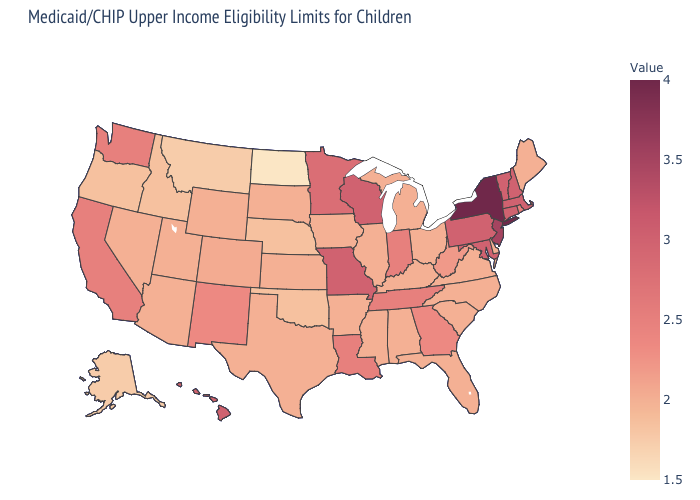Which states have the highest value in the USA?
Answer briefly. New York. Does Wisconsin have the highest value in the MidWest?
Concise answer only. Yes. Among the states that border West Virginia , does Virginia have the highest value?
Be succinct. No. Does North Dakota have the lowest value in the USA?
Concise answer only. Yes. Does Michigan have the highest value in the USA?
Give a very brief answer. No. Does Rhode Island have the lowest value in the Northeast?
Quick response, please. No. Does Wyoming have a higher value than North Dakota?
Answer briefly. Yes. Which states hav the highest value in the South?
Give a very brief answer. Maryland. Does Missouri have the highest value in the USA?
Answer briefly. No. Which states hav the highest value in the MidWest?
Short answer required. Missouri, Wisconsin. Which states have the lowest value in the USA?
Answer briefly. North Dakota. Which states have the highest value in the USA?
Answer briefly. New York. 